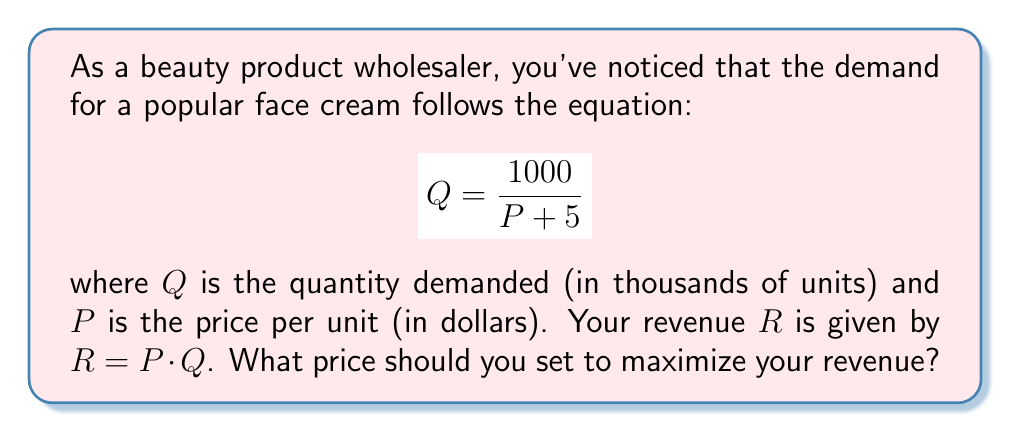Can you solve this math problem? 1) First, let's express revenue $R$ in terms of $P$:
   $$R = P \cdot Q = P \cdot \frac{1000}{P + 5}$$

2) To find the maximum revenue, we need to find the derivative of $R$ with respect to $P$ and set it equal to zero:
   $$\frac{dR}{dP} = \frac{1000}{P + 5} - \frac{1000P}{(P + 5)^2} = \frac{1000(P + 5) - 1000P}{(P + 5)^2} = \frac{1000 \cdot 5}{(P + 5)^2} = \frac{5000}{(P + 5)^2}$$

3) Set this equal to zero and solve:
   $$\frac{5000}{(P + 5)^2} = 0$$
   This equation is never true for real values of $P$, as the numerator is always positive.

4) However, as $P$ approaches infinity, $\frac{dR}{dP}$ approaches 0. This suggests that the revenue function has no local maximum, but rather increases to a horizontal asymptote.

5) To find the horizontal asymptote, we can evaluate the limit of $R$ as $P$ approaches infinity:
   $$\lim_{P \to \infty} R = \lim_{P \to \infty} P \cdot \frac{1000}{P + 5} = 1000$$

6) This means that as the price increases, the revenue approaches but never quite reaches $1000.

7) In practice, we can't set an infinitely high price. The optimal strategy is to set the price as high as the market will bear, while considering factors like competition and customer perception.

8) A reasonable approach would be to set the price where we achieve, say, 95% of the maximum possible revenue:
   $$0.95 \cdot 1000 = P \cdot \frac{1000}{P + 5}$$
   $$950(P + 5) = 1000P$$
   $$4750 = 50P$$
   $$P = 95$$

Therefore, setting the price at $95 will achieve 95% of the maximum possible revenue.
Answer: $95 